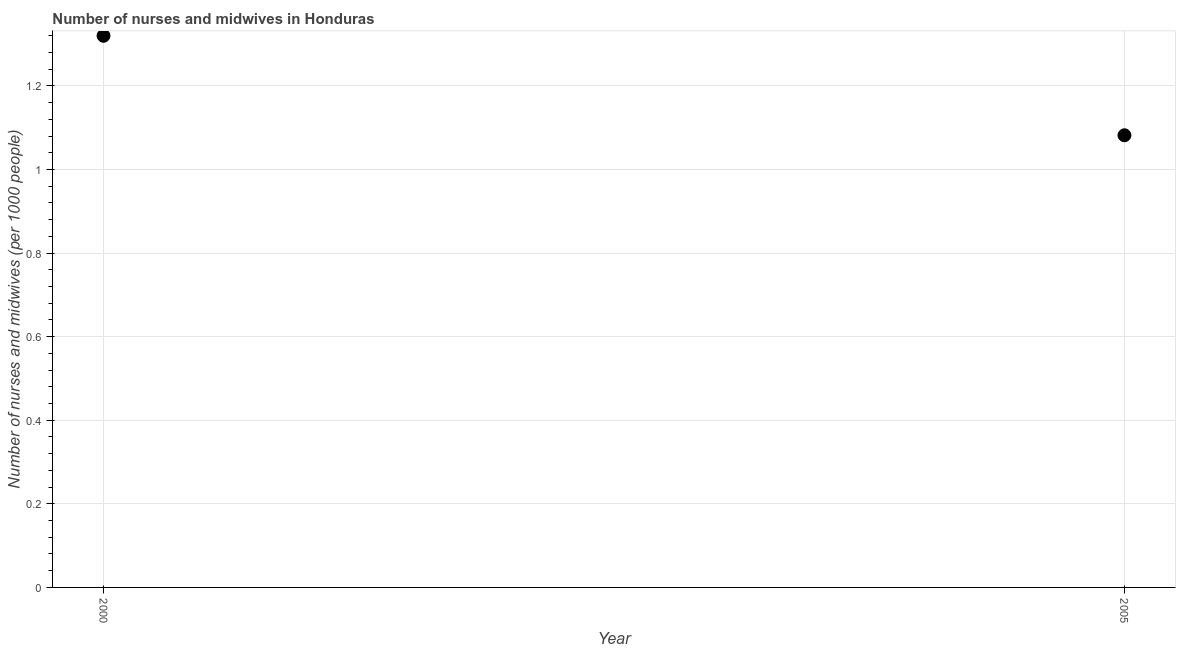What is the number of nurses and midwives in 2000?
Give a very brief answer. 1.32. Across all years, what is the maximum number of nurses and midwives?
Provide a succinct answer. 1.32. Across all years, what is the minimum number of nurses and midwives?
Your answer should be compact. 1.08. What is the sum of the number of nurses and midwives?
Provide a short and direct response. 2.4. What is the difference between the number of nurses and midwives in 2000 and 2005?
Your response must be concise. 0.24. What is the average number of nurses and midwives per year?
Provide a short and direct response. 1.2. What is the median number of nurses and midwives?
Your response must be concise. 1.2. In how many years, is the number of nurses and midwives greater than 0.6400000000000001 ?
Provide a short and direct response. 2. What is the ratio of the number of nurses and midwives in 2000 to that in 2005?
Give a very brief answer. 1.22. What is the difference between two consecutive major ticks on the Y-axis?
Your answer should be compact. 0.2. What is the title of the graph?
Your answer should be very brief. Number of nurses and midwives in Honduras. What is the label or title of the Y-axis?
Ensure brevity in your answer.  Number of nurses and midwives (per 1000 people). What is the Number of nurses and midwives (per 1000 people) in 2000?
Your answer should be compact. 1.32. What is the Number of nurses and midwives (per 1000 people) in 2005?
Provide a succinct answer. 1.08. What is the difference between the Number of nurses and midwives (per 1000 people) in 2000 and 2005?
Offer a very short reply. 0.24. What is the ratio of the Number of nurses and midwives (per 1000 people) in 2000 to that in 2005?
Your response must be concise. 1.22. 